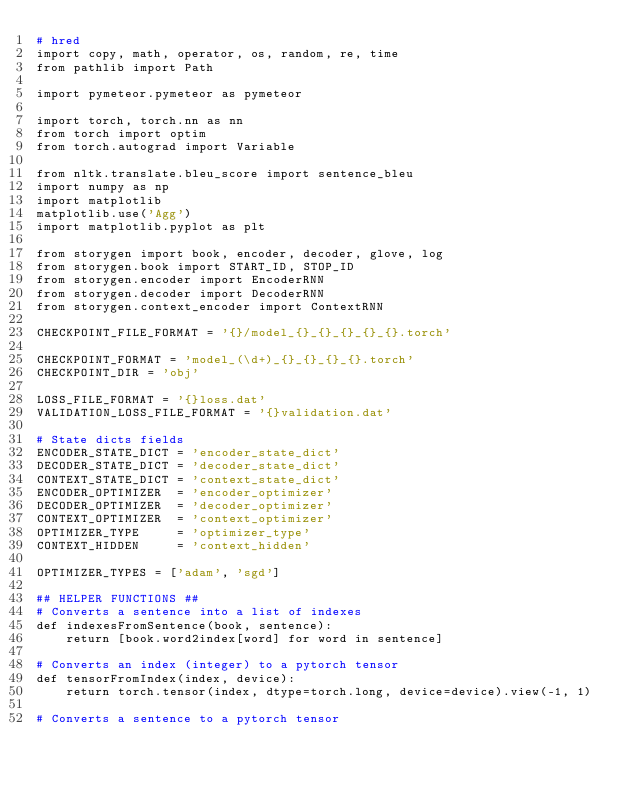<code> <loc_0><loc_0><loc_500><loc_500><_Python_># hred
import copy, math, operator, os, random, re, time
from pathlib import Path

import pymeteor.pymeteor as pymeteor

import torch, torch.nn as nn
from torch import optim
from torch.autograd import Variable

from nltk.translate.bleu_score import sentence_bleu
import numpy as np
import matplotlib
matplotlib.use('Agg')
import matplotlib.pyplot as plt

from storygen import book, encoder, decoder, glove, log
from storygen.book import START_ID, STOP_ID
from storygen.encoder import EncoderRNN
from storygen.decoder import DecoderRNN
from storygen.context_encoder import ContextRNN

CHECKPOINT_FILE_FORMAT = '{}/model_{}_{}_{}_{}_{}.torch'

CHECKPOINT_FORMAT = 'model_(\d+)_{}_{}_{}_{}.torch'
CHECKPOINT_DIR = 'obj'

LOSS_FILE_FORMAT = '{}loss.dat'
VALIDATION_LOSS_FILE_FORMAT = '{}validation.dat'

# State dicts fields
ENCODER_STATE_DICT = 'encoder_state_dict'
DECODER_STATE_DICT = 'decoder_state_dict'
CONTEXT_STATE_DICT = 'context_state_dict'
ENCODER_OPTIMIZER  = 'encoder_optimizer'
DECODER_OPTIMIZER  = 'decoder_optimizer'
CONTEXT_OPTIMIZER  = 'context_optimizer'
OPTIMIZER_TYPE     = 'optimizer_type'
CONTEXT_HIDDEN     = 'context_hidden'

OPTIMIZER_TYPES = ['adam', 'sgd']

## HELPER FUNCTIONS ##
# Converts a sentence into a list of indexes
def indexesFromSentence(book, sentence):
    return [book.word2index[word] for word in sentence]

# Converts an index (integer) to a pytorch tensor
def tensorFromIndex(index, device):
    return torch.tensor(index, dtype=torch.long, device=device).view(-1, 1)

# Converts a sentence to a pytorch tensor</code> 